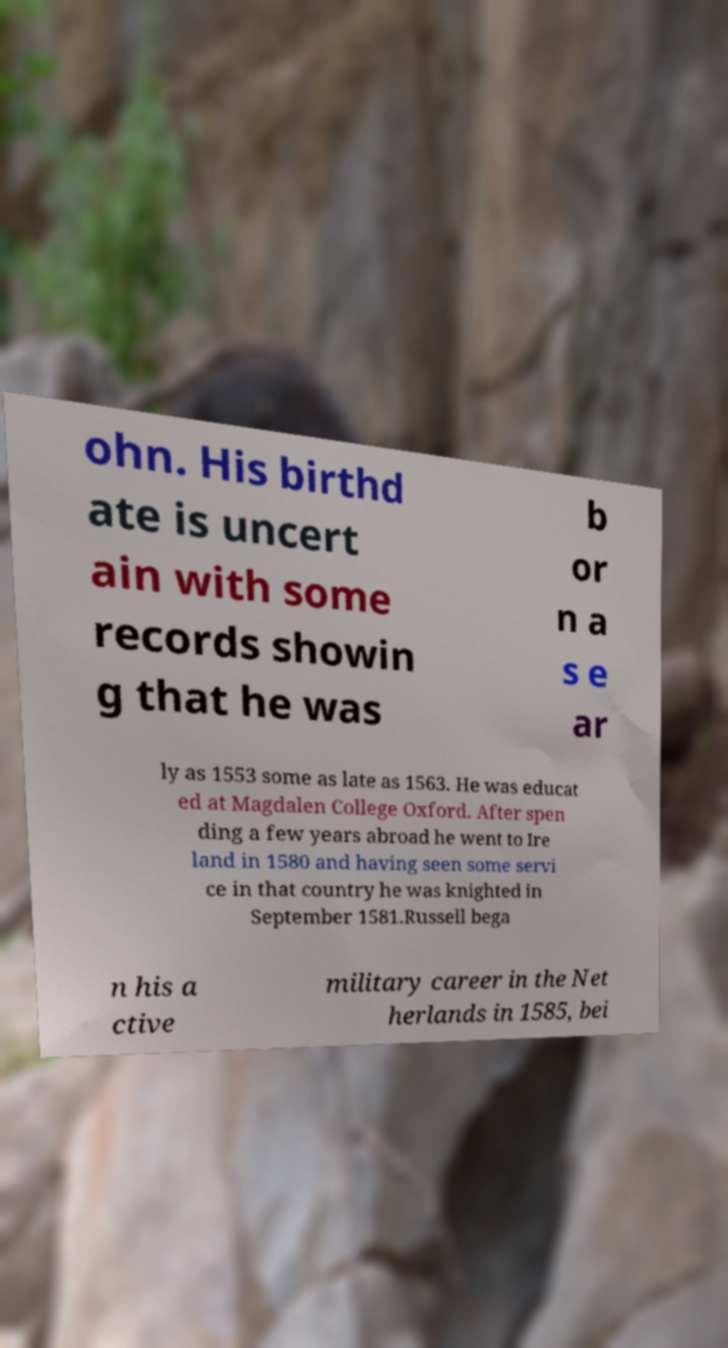Please read and relay the text visible in this image. What does it say? ohn. His birthd ate is uncert ain with some records showin g that he was b or n a s e ar ly as 1553 some as late as 1563. He was educat ed at Magdalen College Oxford. After spen ding a few years abroad he went to Ire land in 1580 and having seen some servi ce in that country he was knighted in September 1581.Russell bega n his a ctive military career in the Net herlands in 1585, bei 